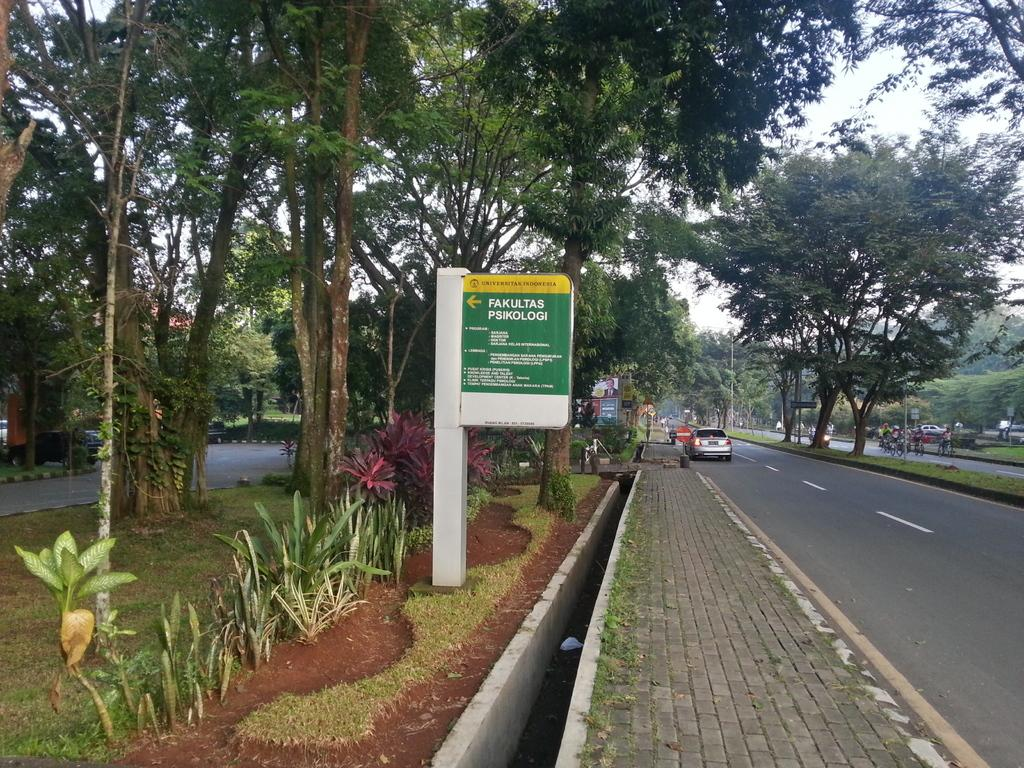What is the main feature of the image? There is a road in the image. Can you describe any vehicles or objects near the road? A vehicle is parked beside the footpath. What is located on the left side of the image? There is a board with text on the left side. What can be seen in the surroundings of the road? There are many trees around the road. What is the rate of the coach passing by in the image? There is no coach present in the image, so it is not possible to determine the rate at which it might be passing by. 